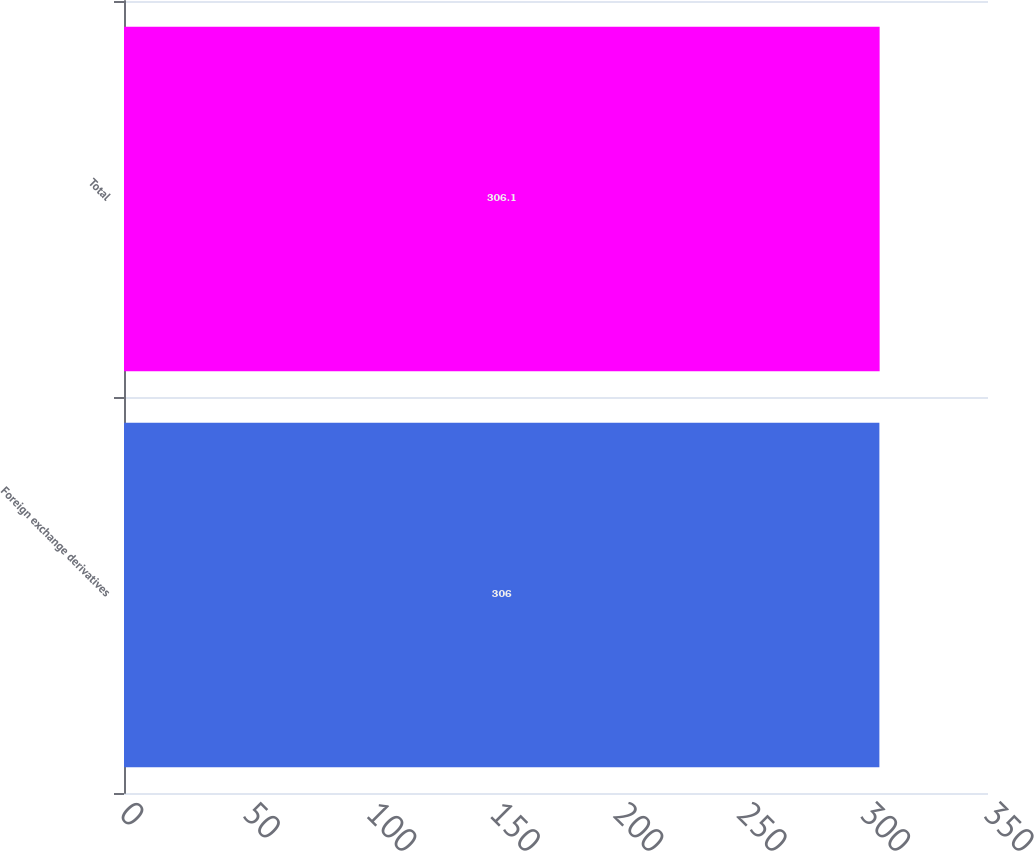Convert chart to OTSL. <chart><loc_0><loc_0><loc_500><loc_500><bar_chart><fcel>Foreign exchange derivatives<fcel>Total<nl><fcel>306<fcel>306.1<nl></chart> 